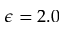Convert formula to latex. <formula><loc_0><loc_0><loc_500><loc_500>\epsilon = 2 . 0</formula> 